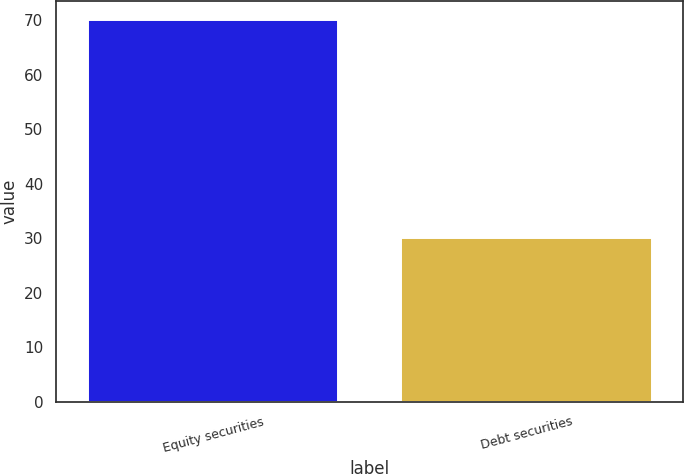<chart> <loc_0><loc_0><loc_500><loc_500><bar_chart><fcel>Equity securities<fcel>Debt securities<nl><fcel>70<fcel>30<nl></chart> 